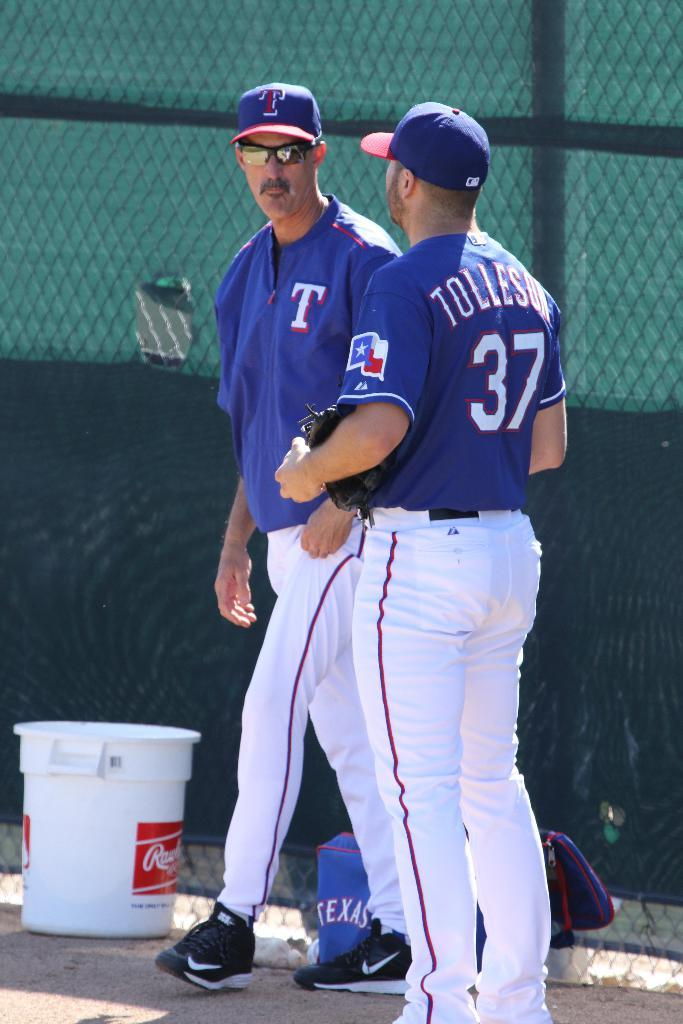<image>
Share a concise interpretation of the image provided. A baseball player wearing a blue number 37 jersey chatting with his coach. 